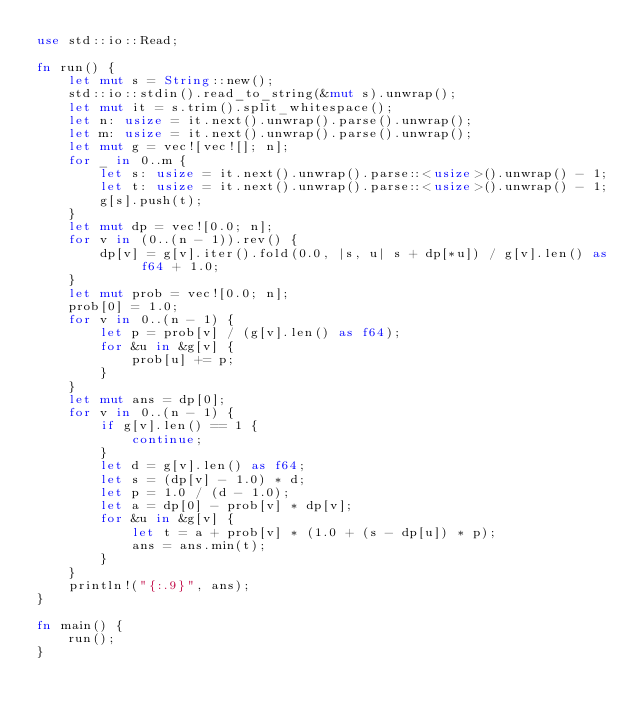<code> <loc_0><loc_0><loc_500><loc_500><_Rust_>use std::io::Read;

fn run() {
    let mut s = String::new();
    std::io::stdin().read_to_string(&mut s).unwrap();
    let mut it = s.trim().split_whitespace();
    let n: usize = it.next().unwrap().parse().unwrap();
    let m: usize = it.next().unwrap().parse().unwrap();
    let mut g = vec![vec![]; n];
    for _ in 0..m {
        let s: usize = it.next().unwrap().parse::<usize>().unwrap() - 1;
        let t: usize = it.next().unwrap().parse::<usize>().unwrap() - 1;
        g[s].push(t);
    }
    let mut dp = vec![0.0; n];
    for v in (0..(n - 1)).rev() {
        dp[v] = g[v].iter().fold(0.0, |s, u| s + dp[*u]) / g[v].len() as f64 + 1.0;
    }
    let mut prob = vec![0.0; n];
    prob[0] = 1.0;
    for v in 0..(n - 1) {
        let p = prob[v] / (g[v].len() as f64);
        for &u in &g[v] {
            prob[u] += p;
        }
    }
    let mut ans = dp[0];
    for v in 0..(n - 1) {
        if g[v].len() == 1 {
            continue;
        }
        let d = g[v].len() as f64;
        let s = (dp[v] - 1.0) * d;
        let p = 1.0 / (d - 1.0);
        let a = dp[0] - prob[v] * dp[v];
        for &u in &g[v] {
            let t = a + prob[v] * (1.0 + (s - dp[u]) * p);
            ans = ans.min(t);
        }
    }
    println!("{:.9}", ans);
}

fn main() {
    run();
}
</code> 